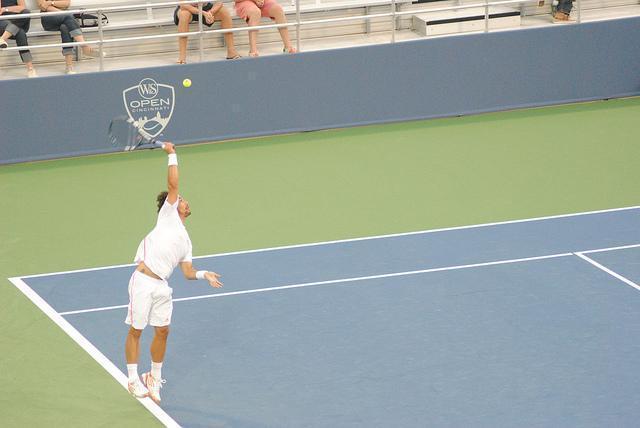What does the W S stand for?
Pick the correct solution from the four options below to address the question.
Options: Washington/state, white/scarlet, world/sport, western/southern. Western/southern. 